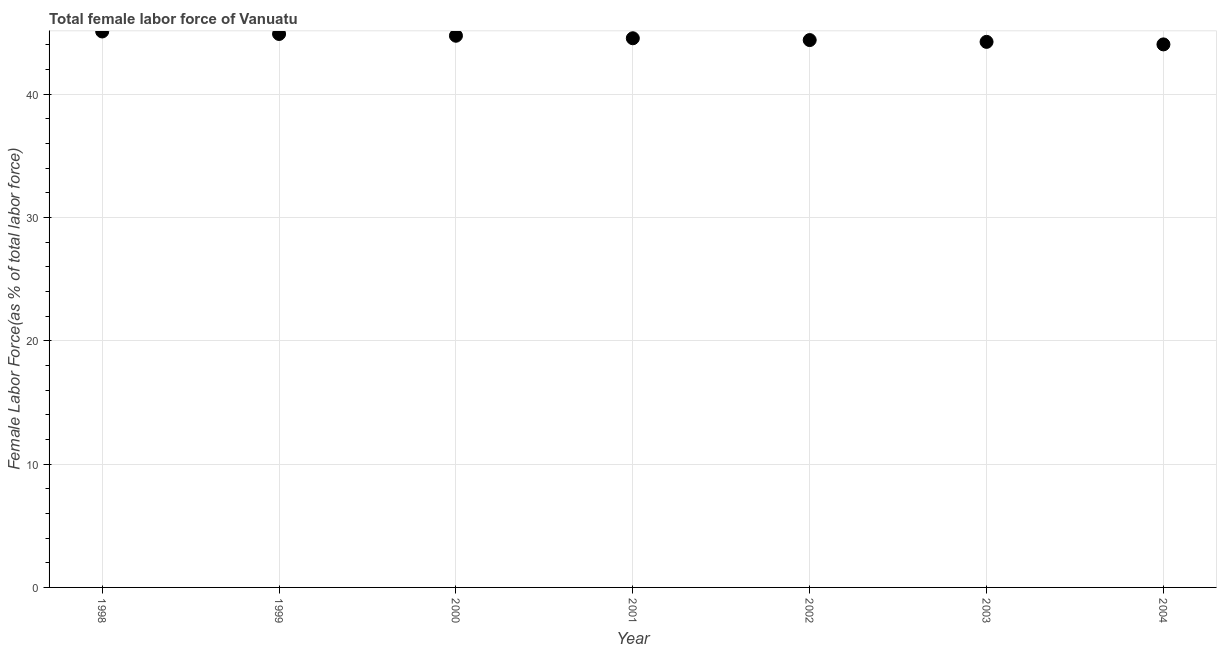What is the total female labor force in 1999?
Your answer should be very brief. 44.89. Across all years, what is the maximum total female labor force?
Your answer should be compact. 45.09. Across all years, what is the minimum total female labor force?
Your response must be concise. 44.04. What is the sum of the total female labor force?
Your answer should be compact. 311.94. What is the difference between the total female labor force in 2000 and 2002?
Provide a short and direct response. 0.35. What is the average total female labor force per year?
Provide a short and direct response. 44.56. What is the median total female labor force?
Provide a short and direct response. 44.54. Do a majority of the years between 1998 and 2002 (inclusive) have total female labor force greater than 6 %?
Provide a short and direct response. Yes. What is the ratio of the total female labor force in 1998 to that in 2004?
Offer a terse response. 1.02. What is the difference between the highest and the second highest total female labor force?
Offer a terse response. 0.2. What is the difference between the highest and the lowest total female labor force?
Keep it short and to the point. 1.05. In how many years, is the total female labor force greater than the average total female labor force taken over all years?
Offer a terse response. 3. Does the total female labor force monotonically increase over the years?
Provide a short and direct response. No. What is the difference between two consecutive major ticks on the Y-axis?
Ensure brevity in your answer.  10. Does the graph contain any zero values?
Keep it short and to the point. No. Does the graph contain grids?
Provide a short and direct response. Yes. What is the title of the graph?
Offer a very short reply. Total female labor force of Vanuatu. What is the label or title of the Y-axis?
Offer a very short reply. Female Labor Force(as % of total labor force). What is the Female Labor Force(as % of total labor force) in 1998?
Make the answer very short. 45.09. What is the Female Labor Force(as % of total labor force) in 1999?
Offer a terse response. 44.89. What is the Female Labor Force(as % of total labor force) in 2000?
Offer a terse response. 44.74. What is the Female Labor Force(as % of total labor force) in 2001?
Ensure brevity in your answer.  44.54. What is the Female Labor Force(as % of total labor force) in 2002?
Provide a short and direct response. 44.39. What is the Female Labor Force(as % of total labor force) in 2003?
Offer a very short reply. 44.25. What is the Female Labor Force(as % of total labor force) in 2004?
Your response must be concise. 44.04. What is the difference between the Female Labor Force(as % of total labor force) in 1998 and 1999?
Keep it short and to the point. 0.2. What is the difference between the Female Labor Force(as % of total labor force) in 1998 and 2000?
Offer a terse response. 0.35. What is the difference between the Female Labor Force(as % of total labor force) in 1998 and 2001?
Your answer should be very brief. 0.55. What is the difference between the Female Labor Force(as % of total labor force) in 1998 and 2002?
Your answer should be very brief. 0.7. What is the difference between the Female Labor Force(as % of total labor force) in 1998 and 2003?
Provide a short and direct response. 0.84. What is the difference between the Female Labor Force(as % of total labor force) in 1998 and 2004?
Ensure brevity in your answer.  1.05. What is the difference between the Female Labor Force(as % of total labor force) in 1999 and 2000?
Provide a succinct answer. 0.14. What is the difference between the Female Labor Force(as % of total labor force) in 1999 and 2001?
Offer a terse response. 0.35. What is the difference between the Female Labor Force(as % of total labor force) in 1999 and 2002?
Keep it short and to the point. 0.49. What is the difference between the Female Labor Force(as % of total labor force) in 1999 and 2003?
Your response must be concise. 0.64. What is the difference between the Female Labor Force(as % of total labor force) in 1999 and 2004?
Your response must be concise. 0.85. What is the difference between the Female Labor Force(as % of total labor force) in 2000 and 2001?
Your answer should be compact. 0.2. What is the difference between the Female Labor Force(as % of total labor force) in 2000 and 2002?
Your answer should be very brief. 0.35. What is the difference between the Female Labor Force(as % of total labor force) in 2000 and 2003?
Make the answer very short. 0.5. What is the difference between the Female Labor Force(as % of total labor force) in 2000 and 2004?
Offer a terse response. 0.7. What is the difference between the Female Labor Force(as % of total labor force) in 2001 and 2002?
Your response must be concise. 0.15. What is the difference between the Female Labor Force(as % of total labor force) in 2001 and 2003?
Offer a very short reply. 0.29. What is the difference between the Female Labor Force(as % of total labor force) in 2001 and 2004?
Offer a terse response. 0.5. What is the difference between the Female Labor Force(as % of total labor force) in 2002 and 2003?
Make the answer very short. 0.15. What is the difference between the Female Labor Force(as % of total labor force) in 2002 and 2004?
Offer a terse response. 0.35. What is the difference between the Female Labor Force(as % of total labor force) in 2003 and 2004?
Provide a short and direct response. 0.2. What is the ratio of the Female Labor Force(as % of total labor force) in 1998 to that in 1999?
Offer a very short reply. 1. What is the ratio of the Female Labor Force(as % of total labor force) in 1998 to that in 2000?
Ensure brevity in your answer.  1.01. What is the ratio of the Female Labor Force(as % of total labor force) in 1998 to that in 2003?
Offer a very short reply. 1.02. What is the ratio of the Female Labor Force(as % of total labor force) in 1998 to that in 2004?
Offer a terse response. 1.02. What is the ratio of the Female Labor Force(as % of total labor force) in 1999 to that in 2001?
Your answer should be very brief. 1.01. What is the ratio of the Female Labor Force(as % of total labor force) in 1999 to that in 2002?
Provide a short and direct response. 1.01. What is the ratio of the Female Labor Force(as % of total labor force) in 1999 to that in 2003?
Offer a terse response. 1.01. What is the ratio of the Female Labor Force(as % of total labor force) in 1999 to that in 2004?
Your answer should be very brief. 1.02. What is the ratio of the Female Labor Force(as % of total labor force) in 2000 to that in 2004?
Make the answer very short. 1.02. What is the ratio of the Female Labor Force(as % of total labor force) in 2001 to that in 2002?
Ensure brevity in your answer.  1. What is the ratio of the Female Labor Force(as % of total labor force) in 2002 to that in 2003?
Your response must be concise. 1. What is the ratio of the Female Labor Force(as % of total labor force) in 2002 to that in 2004?
Ensure brevity in your answer.  1.01. What is the ratio of the Female Labor Force(as % of total labor force) in 2003 to that in 2004?
Give a very brief answer. 1. 